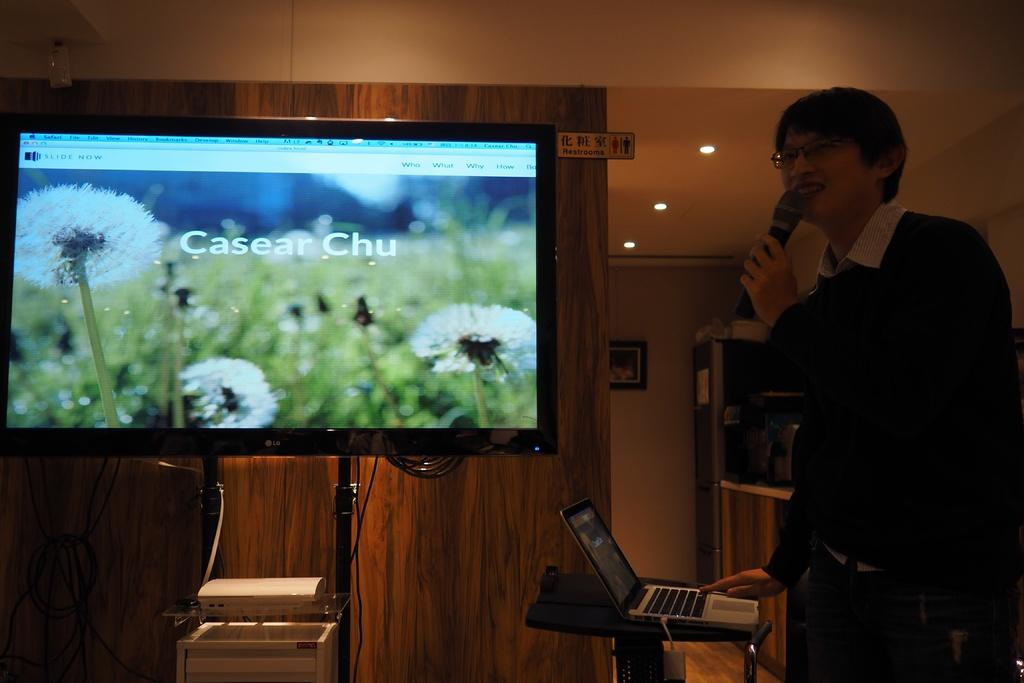<image>
Offer a succinct explanation of the picture presented. As a man is speaking into a microphone, the tv display has an image of a field of dandelions with the name Casear Chu written across it. 